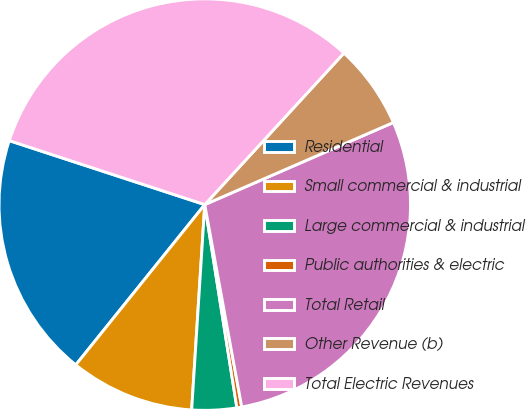Convert chart. <chart><loc_0><loc_0><loc_500><loc_500><pie_chart><fcel>Residential<fcel>Small commercial & industrial<fcel>Large commercial & industrial<fcel>Public authorities & electric<fcel>Total Retail<fcel>Other Revenue (b)<fcel>Total Electric Revenues<nl><fcel>19.25%<fcel>9.77%<fcel>3.51%<fcel>0.38%<fcel>28.66%<fcel>6.64%<fcel>31.79%<nl></chart> 